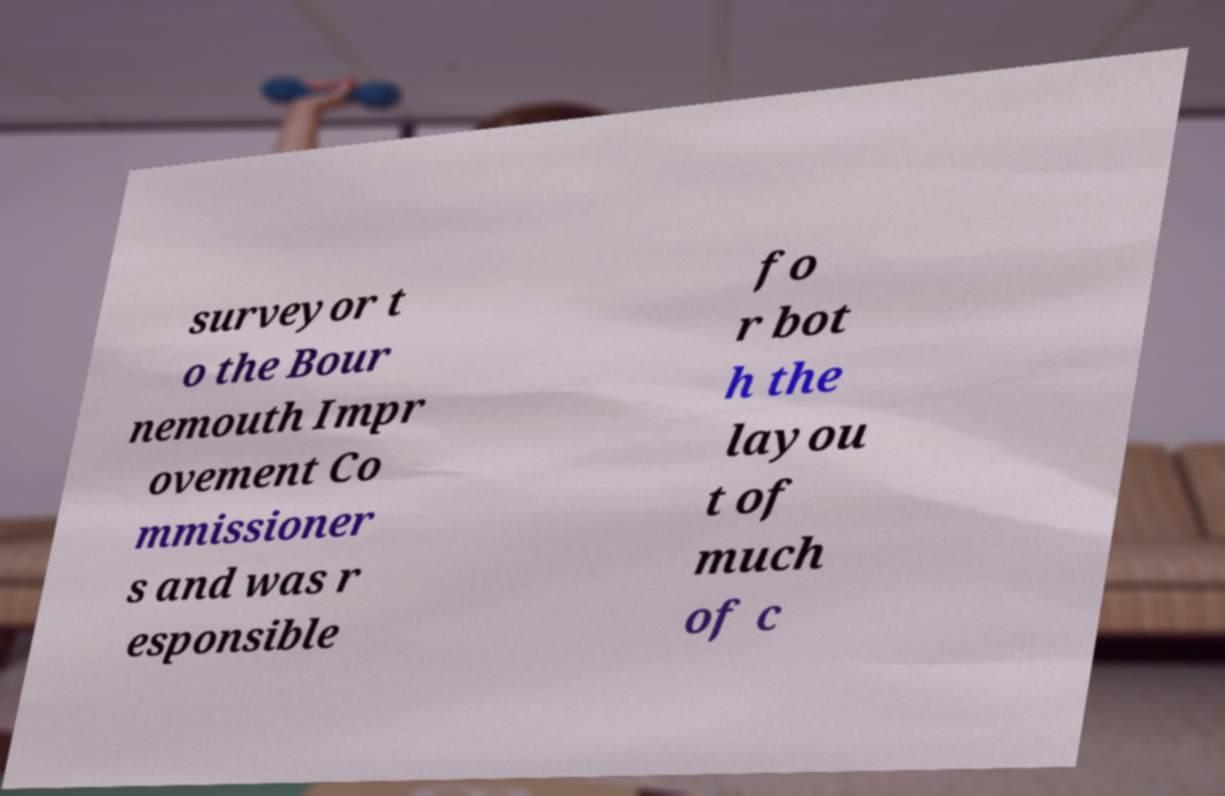I need the written content from this picture converted into text. Can you do that? surveyor t o the Bour nemouth Impr ovement Co mmissioner s and was r esponsible fo r bot h the layou t of much of c 